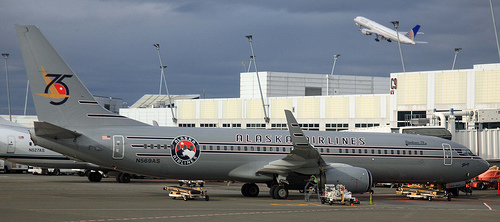What type of vehicle is primarily featured in this image? The primary vehicle featured is a commercial passenger airplane, specifically painted in the livery of Alaska Airlines. 